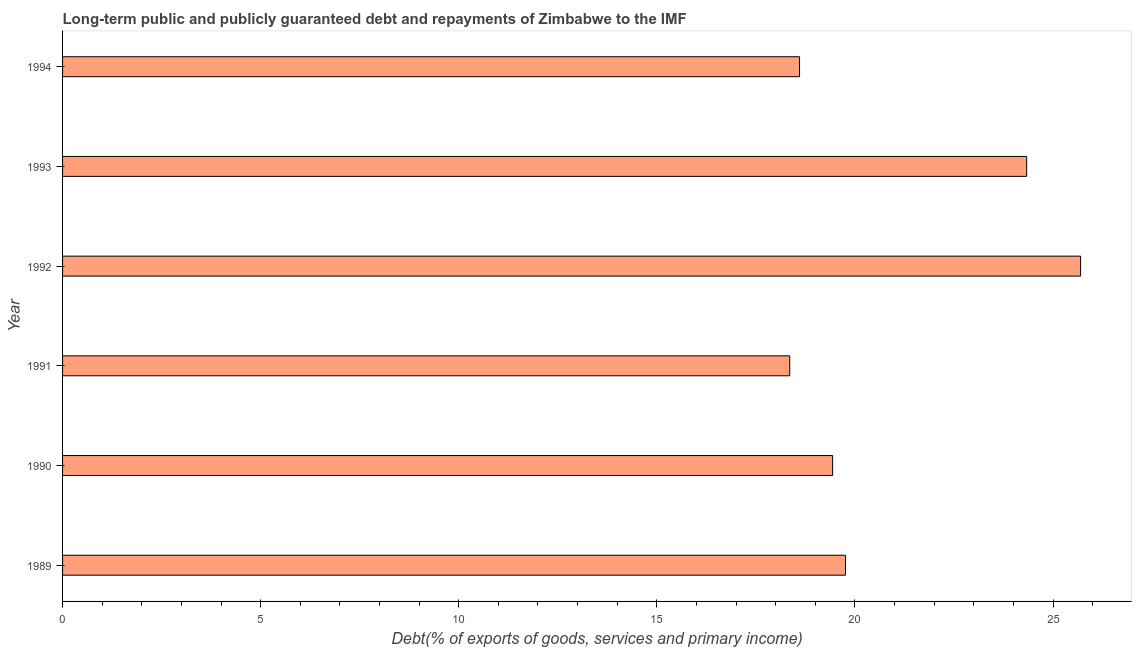Does the graph contain any zero values?
Provide a short and direct response. No. What is the title of the graph?
Offer a very short reply. Long-term public and publicly guaranteed debt and repayments of Zimbabwe to the IMF. What is the label or title of the X-axis?
Give a very brief answer. Debt(% of exports of goods, services and primary income). What is the debt service in 1991?
Your answer should be very brief. 18.35. Across all years, what is the maximum debt service?
Give a very brief answer. 25.7. Across all years, what is the minimum debt service?
Your answer should be compact. 18.35. In which year was the debt service minimum?
Keep it short and to the point. 1991. What is the sum of the debt service?
Provide a succinct answer. 126.19. What is the difference between the debt service in 1991 and 1994?
Provide a short and direct response. -0.25. What is the average debt service per year?
Keep it short and to the point. 21.03. What is the median debt service?
Offer a very short reply. 19.6. What is the ratio of the debt service in 1990 to that in 1992?
Offer a very short reply. 0.76. What is the difference between the highest and the second highest debt service?
Your answer should be compact. 1.36. Is the sum of the debt service in 1989 and 1992 greater than the maximum debt service across all years?
Provide a short and direct response. Yes. What is the difference between the highest and the lowest debt service?
Offer a very short reply. 7.34. In how many years, is the debt service greater than the average debt service taken over all years?
Give a very brief answer. 2. Are all the bars in the graph horizontal?
Your answer should be compact. Yes. How many years are there in the graph?
Ensure brevity in your answer.  6. What is the difference between two consecutive major ticks on the X-axis?
Your answer should be compact. 5. What is the Debt(% of exports of goods, services and primary income) in 1989?
Ensure brevity in your answer.  19.76. What is the Debt(% of exports of goods, services and primary income) in 1990?
Provide a short and direct response. 19.44. What is the Debt(% of exports of goods, services and primary income) of 1991?
Offer a very short reply. 18.35. What is the Debt(% of exports of goods, services and primary income) of 1992?
Your answer should be compact. 25.7. What is the Debt(% of exports of goods, services and primary income) of 1993?
Offer a terse response. 24.33. What is the Debt(% of exports of goods, services and primary income) in 1994?
Give a very brief answer. 18.6. What is the difference between the Debt(% of exports of goods, services and primary income) in 1989 and 1990?
Offer a terse response. 0.32. What is the difference between the Debt(% of exports of goods, services and primary income) in 1989 and 1991?
Offer a very short reply. 1.41. What is the difference between the Debt(% of exports of goods, services and primary income) in 1989 and 1992?
Your answer should be compact. -5.93. What is the difference between the Debt(% of exports of goods, services and primary income) in 1989 and 1993?
Provide a succinct answer. -4.57. What is the difference between the Debt(% of exports of goods, services and primary income) in 1989 and 1994?
Your answer should be very brief. 1.16. What is the difference between the Debt(% of exports of goods, services and primary income) in 1990 and 1991?
Provide a succinct answer. 1.08. What is the difference between the Debt(% of exports of goods, services and primary income) in 1990 and 1992?
Provide a succinct answer. -6.26. What is the difference between the Debt(% of exports of goods, services and primary income) in 1990 and 1993?
Provide a succinct answer. -4.9. What is the difference between the Debt(% of exports of goods, services and primary income) in 1990 and 1994?
Your answer should be very brief. 0.84. What is the difference between the Debt(% of exports of goods, services and primary income) in 1991 and 1992?
Give a very brief answer. -7.34. What is the difference between the Debt(% of exports of goods, services and primary income) in 1991 and 1993?
Make the answer very short. -5.98. What is the difference between the Debt(% of exports of goods, services and primary income) in 1991 and 1994?
Offer a very short reply. -0.25. What is the difference between the Debt(% of exports of goods, services and primary income) in 1992 and 1993?
Give a very brief answer. 1.36. What is the difference between the Debt(% of exports of goods, services and primary income) in 1992 and 1994?
Provide a succinct answer. 7.09. What is the difference between the Debt(% of exports of goods, services and primary income) in 1993 and 1994?
Your answer should be compact. 5.73. What is the ratio of the Debt(% of exports of goods, services and primary income) in 1989 to that in 1990?
Keep it short and to the point. 1.02. What is the ratio of the Debt(% of exports of goods, services and primary income) in 1989 to that in 1991?
Ensure brevity in your answer.  1.08. What is the ratio of the Debt(% of exports of goods, services and primary income) in 1989 to that in 1992?
Your response must be concise. 0.77. What is the ratio of the Debt(% of exports of goods, services and primary income) in 1989 to that in 1993?
Offer a very short reply. 0.81. What is the ratio of the Debt(% of exports of goods, services and primary income) in 1989 to that in 1994?
Keep it short and to the point. 1.06. What is the ratio of the Debt(% of exports of goods, services and primary income) in 1990 to that in 1991?
Provide a succinct answer. 1.06. What is the ratio of the Debt(% of exports of goods, services and primary income) in 1990 to that in 1992?
Provide a short and direct response. 0.76. What is the ratio of the Debt(% of exports of goods, services and primary income) in 1990 to that in 1993?
Your answer should be compact. 0.8. What is the ratio of the Debt(% of exports of goods, services and primary income) in 1990 to that in 1994?
Your response must be concise. 1.04. What is the ratio of the Debt(% of exports of goods, services and primary income) in 1991 to that in 1992?
Provide a succinct answer. 0.71. What is the ratio of the Debt(% of exports of goods, services and primary income) in 1991 to that in 1993?
Keep it short and to the point. 0.75. What is the ratio of the Debt(% of exports of goods, services and primary income) in 1991 to that in 1994?
Ensure brevity in your answer.  0.99. What is the ratio of the Debt(% of exports of goods, services and primary income) in 1992 to that in 1993?
Give a very brief answer. 1.06. What is the ratio of the Debt(% of exports of goods, services and primary income) in 1992 to that in 1994?
Offer a terse response. 1.38. What is the ratio of the Debt(% of exports of goods, services and primary income) in 1993 to that in 1994?
Offer a terse response. 1.31. 